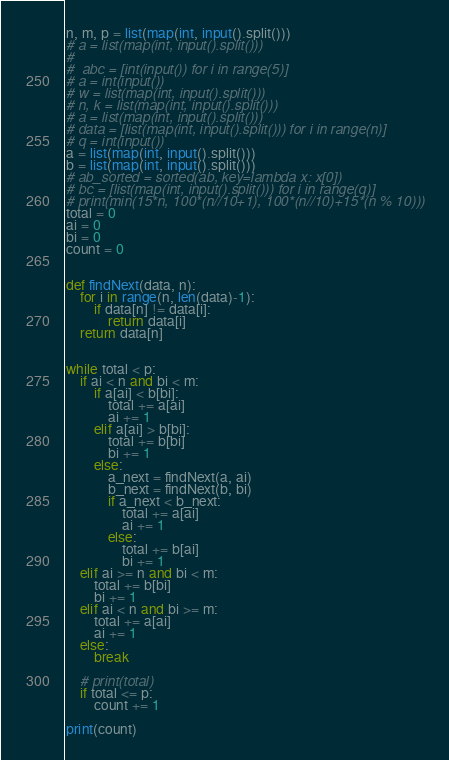Convert code to text. <code><loc_0><loc_0><loc_500><loc_500><_Python_>n, m, p = list(map(int, input().split()))
# a = list(map(int, input().split()))
#
#  abc = [int(input()) for i in range(5)]
# a = int(input())
# w = list(map(int, input().split()))
# n, k = list(map(int, input().split()))
# a = list(map(int, input().split()))
# data = [list(map(int, input().split())) for i in range(n)]
# q = int(input())
a = list(map(int, input().split()))
b = list(map(int, input().split()))
# ab_sorted = sorted(ab, key=lambda x: x[0])
# bc = [list(map(int, input().split())) for i in range(q)]
# print(min(15*n, 100*(n//10+1), 100*(n//10)+15*(n % 10)))
total = 0
ai = 0
bi = 0
count = 0


def findNext(data, n):
    for i in range(n, len(data)-1):
        if data[n] != data[i]:
            return data[i]
    return data[n]


while total < p:
    if ai < n and bi < m:
        if a[ai] < b[bi]:
            total += a[ai]
            ai += 1
        elif a[ai] > b[bi]:
            total += b[bi]
            bi += 1
        else:
            a_next = findNext(a, ai)
            b_next = findNext(b, bi)
            if a_next < b_next:
                total += a[ai]
                ai += 1
            else:
                total += b[ai]
                bi += 1
    elif ai >= n and bi < m:
        total += b[bi]
        bi += 1
    elif ai < n and bi >= m:
        total += a[ai]
        ai += 1
    else:
        break

    # print(total)
    if total <= p:
        count += 1

print(count)
</code> 